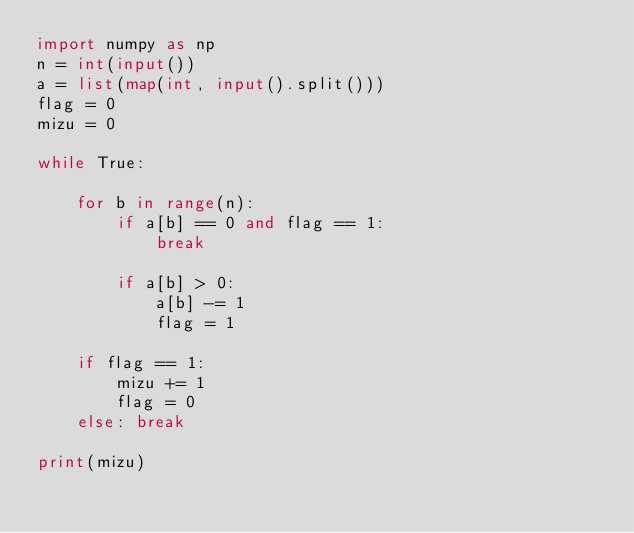Convert code to text. <code><loc_0><loc_0><loc_500><loc_500><_Python_>import numpy as np
n = int(input())
a = list(map(int, input().split()))
flag = 0
mizu = 0

while True:

    for b in range(n):
        if a[b] == 0 and flag == 1:
            break

        if a[b] > 0:
            a[b] -= 1
            flag = 1
    
    if flag == 1:
        mizu += 1
        flag = 0
    else: break

print(mizu)</code> 